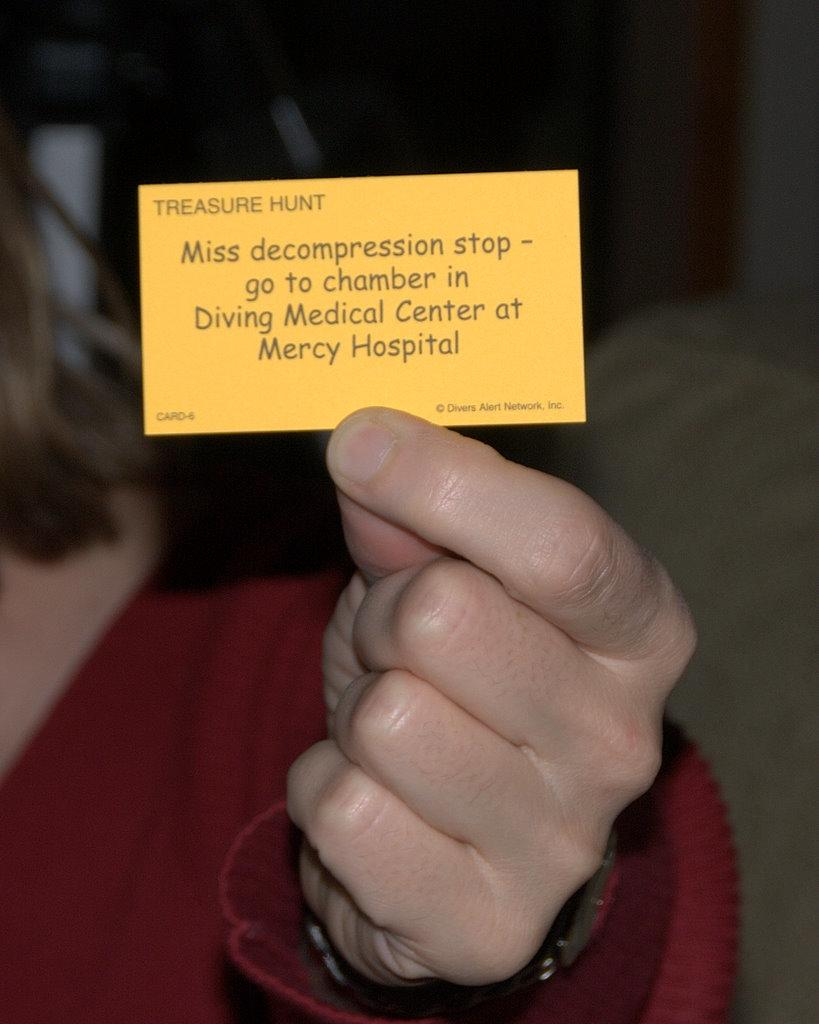What is present in the image? There is a person in the image. What is the person holding in her hand? The person is holding a card in her hand. What type of skin is visible on the person's hand in the image? There is no specific detail about the person's skin visible in the image, so it cannot be determined from the image alone. 